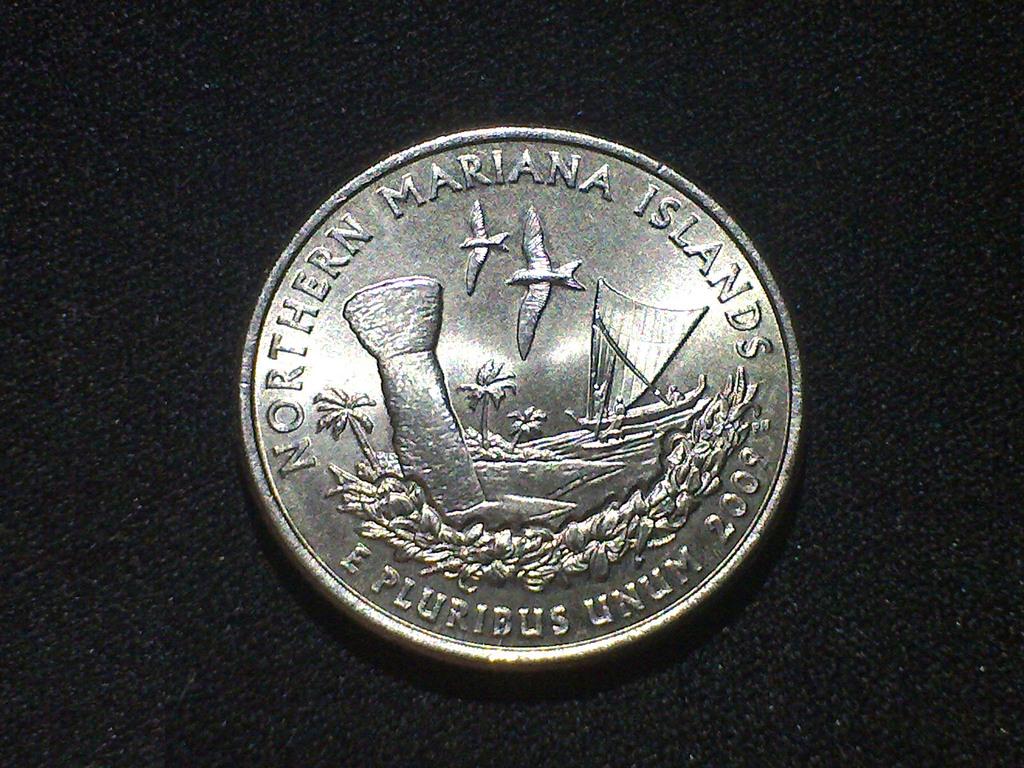What is printed on the top of the coin?
Ensure brevity in your answer.  Northern mariana islands. 